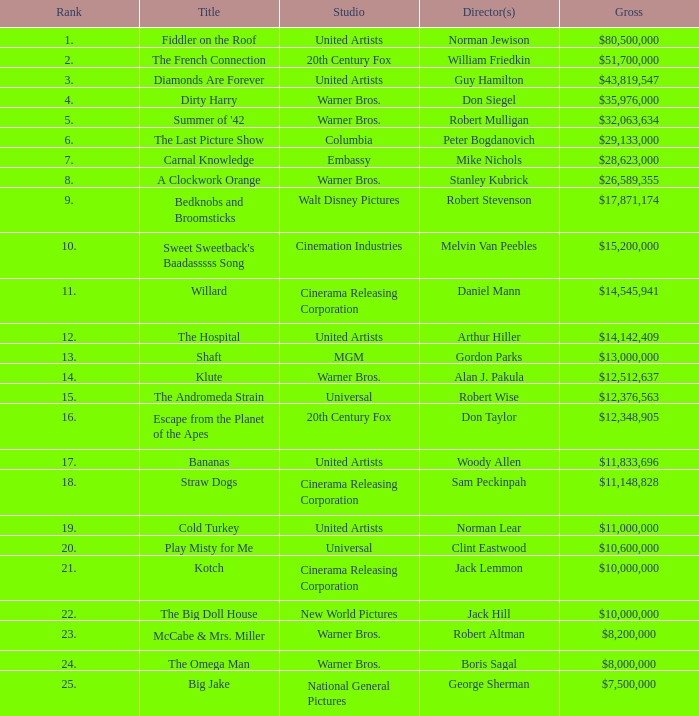What rank is the title with a gross of $26,589,355? 8.0. Can you parse all the data within this table? {'header': ['Rank', 'Title', 'Studio', 'Director(s)', 'Gross'], 'rows': [['1.', 'Fiddler on the Roof', 'United Artists', 'Norman Jewison', '$80,500,000'], ['2.', 'The French Connection', '20th Century Fox', 'William Friedkin', '$51,700,000'], ['3.', 'Diamonds Are Forever', 'United Artists', 'Guy Hamilton', '$43,819,547'], ['4.', 'Dirty Harry', 'Warner Bros.', 'Don Siegel', '$35,976,000'], ['5.', "Summer of '42", 'Warner Bros.', 'Robert Mulligan', '$32,063,634'], ['6.', 'The Last Picture Show', 'Columbia', 'Peter Bogdanovich', '$29,133,000'], ['7.', 'Carnal Knowledge', 'Embassy', 'Mike Nichols', '$28,623,000'], ['8.', 'A Clockwork Orange', 'Warner Bros.', 'Stanley Kubrick', '$26,589,355'], ['9.', 'Bedknobs and Broomsticks', 'Walt Disney Pictures', 'Robert Stevenson', '$17,871,174'], ['10.', "Sweet Sweetback's Baadasssss Song", 'Cinemation Industries', 'Melvin Van Peebles', '$15,200,000'], ['11.', 'Willard', 'Cinerama Releasing Corporation', 'Daniel Mann', '$14,545,941'], ['12.', 'The Hospital', 'United Artists', 'Arthur Hiller', '$14,142,409'], ['13.', 'Shaft', 'MGM', 'Gordon Parks', '$13,000,000'], ['14.', 'Klute', 'Warner Bros.', 'Alan J. Pakula', '$12,512,637'], ['15.', 'The Andromeda Strain', 'Universal', 'Robert Wise', '$12,376,563'], ['16.', 'Escape from the Planet of the Apes', '20th Century Fox', 'Don Taylor', '$12,348,905'], ['17.', 'Bananas', 'United Artists', 'Woody Allen', '$11,833,696'], ['18.', 'Straw Dogs', 'Cinerama Releasing Corporation', 'Sam Peckinpah', '$11,148,828'], ['19.', 'Cold Turkey', 'United Artists', 'Norman Lear', '$11,000,000'], ['20.', 'Play Misty for Me', 'Universal', 'Clint Eastwood', '$10,600,000'], ['21.', 'Kotch', 'Cinerama Releasing Corporation', 'Jack Lemmon', '$10,000,000'], ['22.', 'The Big Doll House', 'New World Pictures', 'Jack Hill', '$10,000,000'], ['23.', 'McCabe & Mrs. Miller', 'Warner Bros.', 'Robert Altman', '$8,200,000'], ['24.', 'The Omega Man', 'Warner Bros.', 'Boris Sagal', '$8,000,000'], ['25.', 'Big Jake', 'National General Pictures', 'George Sherman', '$7,500,000']]} 